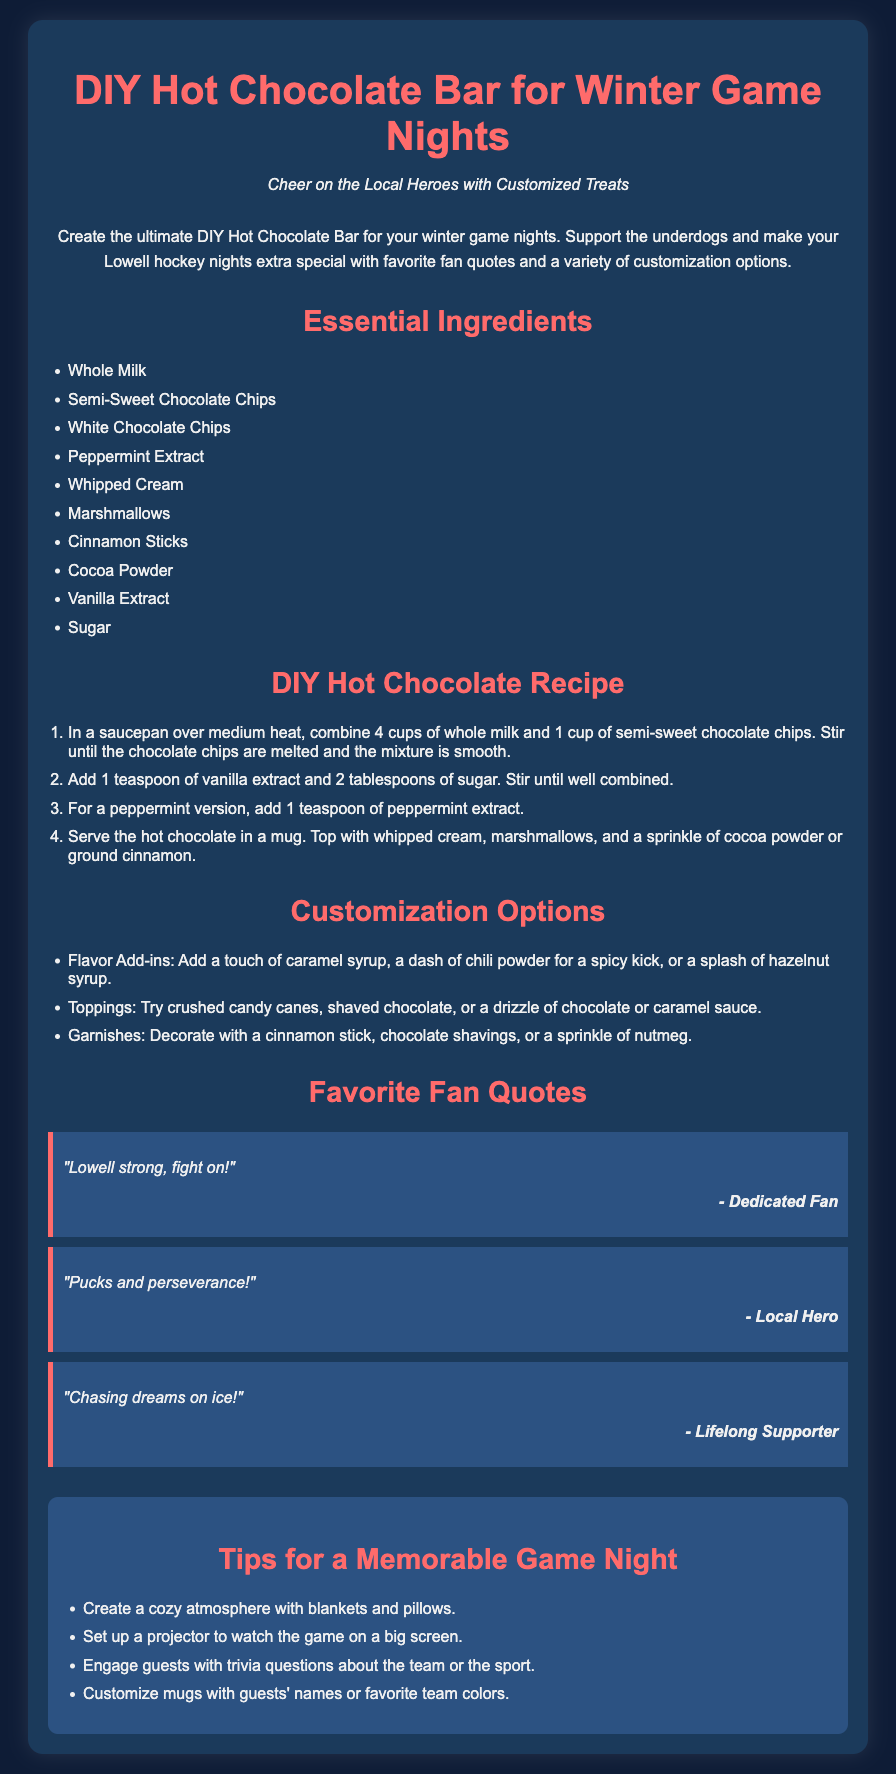what is the main theme of the document? The document focuses on creating an enjoyable hot chocolate bar experience during winter game nights.
Answer: DIY Hot Chocolate Bar for Winter Game Nights how many essential ingredients are listed? There are ten ingredients listed in the essential ingredients section of the document.
Answer: 10 what is one flavor add-in option mentioned? The document provides various customization options, including flavor add-ins. One add-in is caramel syrup.
Answer: caramel syrup who is the author of the quote "Lowell strong, fight on!"? This quote is attributed to a dedicated fan within the quotes section of the document.
Answer: Dedicated Fan what should you serve the hot chocolate in? The document specifies serving the hot chocolate in a mug.
Answer: mug what is one suggested topping for the hot chocolate? Among the toppings mentioned, crushed candy canes are one of the options suggested.
Answer: crushed candy canes what is one tip for creating a cozy atmosphere? One suggestion for a memorable game night is to create a cozy atmosphere with blankets and pillows.
Answer: blankets and pillows how many quotes are included in the Favorite Fan Quotes section? The Favorite Fan Quotes section includes three quotes from different fans.
Answer: 3 what should you do to customize mugs? The document suggests customizing mugs with guests' names or favorite team colors.
Answer: guests' names or favorite team colors 